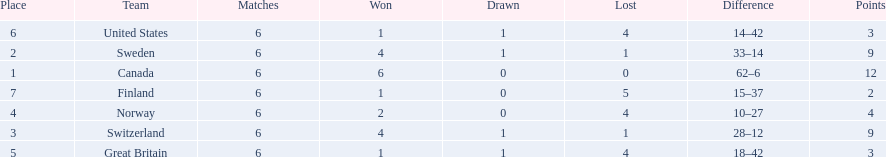What are all the teams? Canada, Sweden, Switzerland, Norway, Great Britain, United States, Finland. What were their points? 12, 9, 9, 4, 3, 3, 2. What about just switzerland and great britain? 9, 3. Now, which of those teams scored higher? Switzerland. 